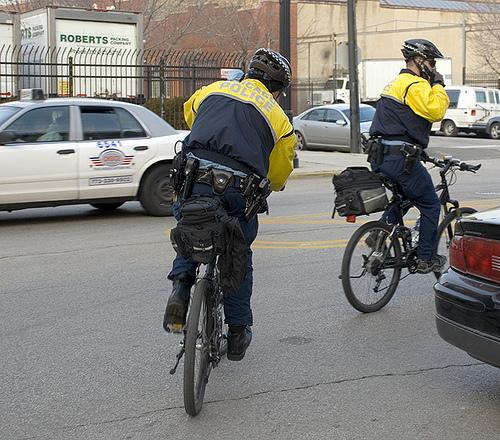What public service department do the men work for?
Keep it brief. Police. What is the cop sitting on?
Answer briefly. Bicycle. Is one of the bicyclist on the phone?
Concise answer only. Yes. What color is the bike?
Be succinct. Black. How many bikes are there?
Answer briefly. 2. Is this two men, or two women?
Quick response, please. Men. 